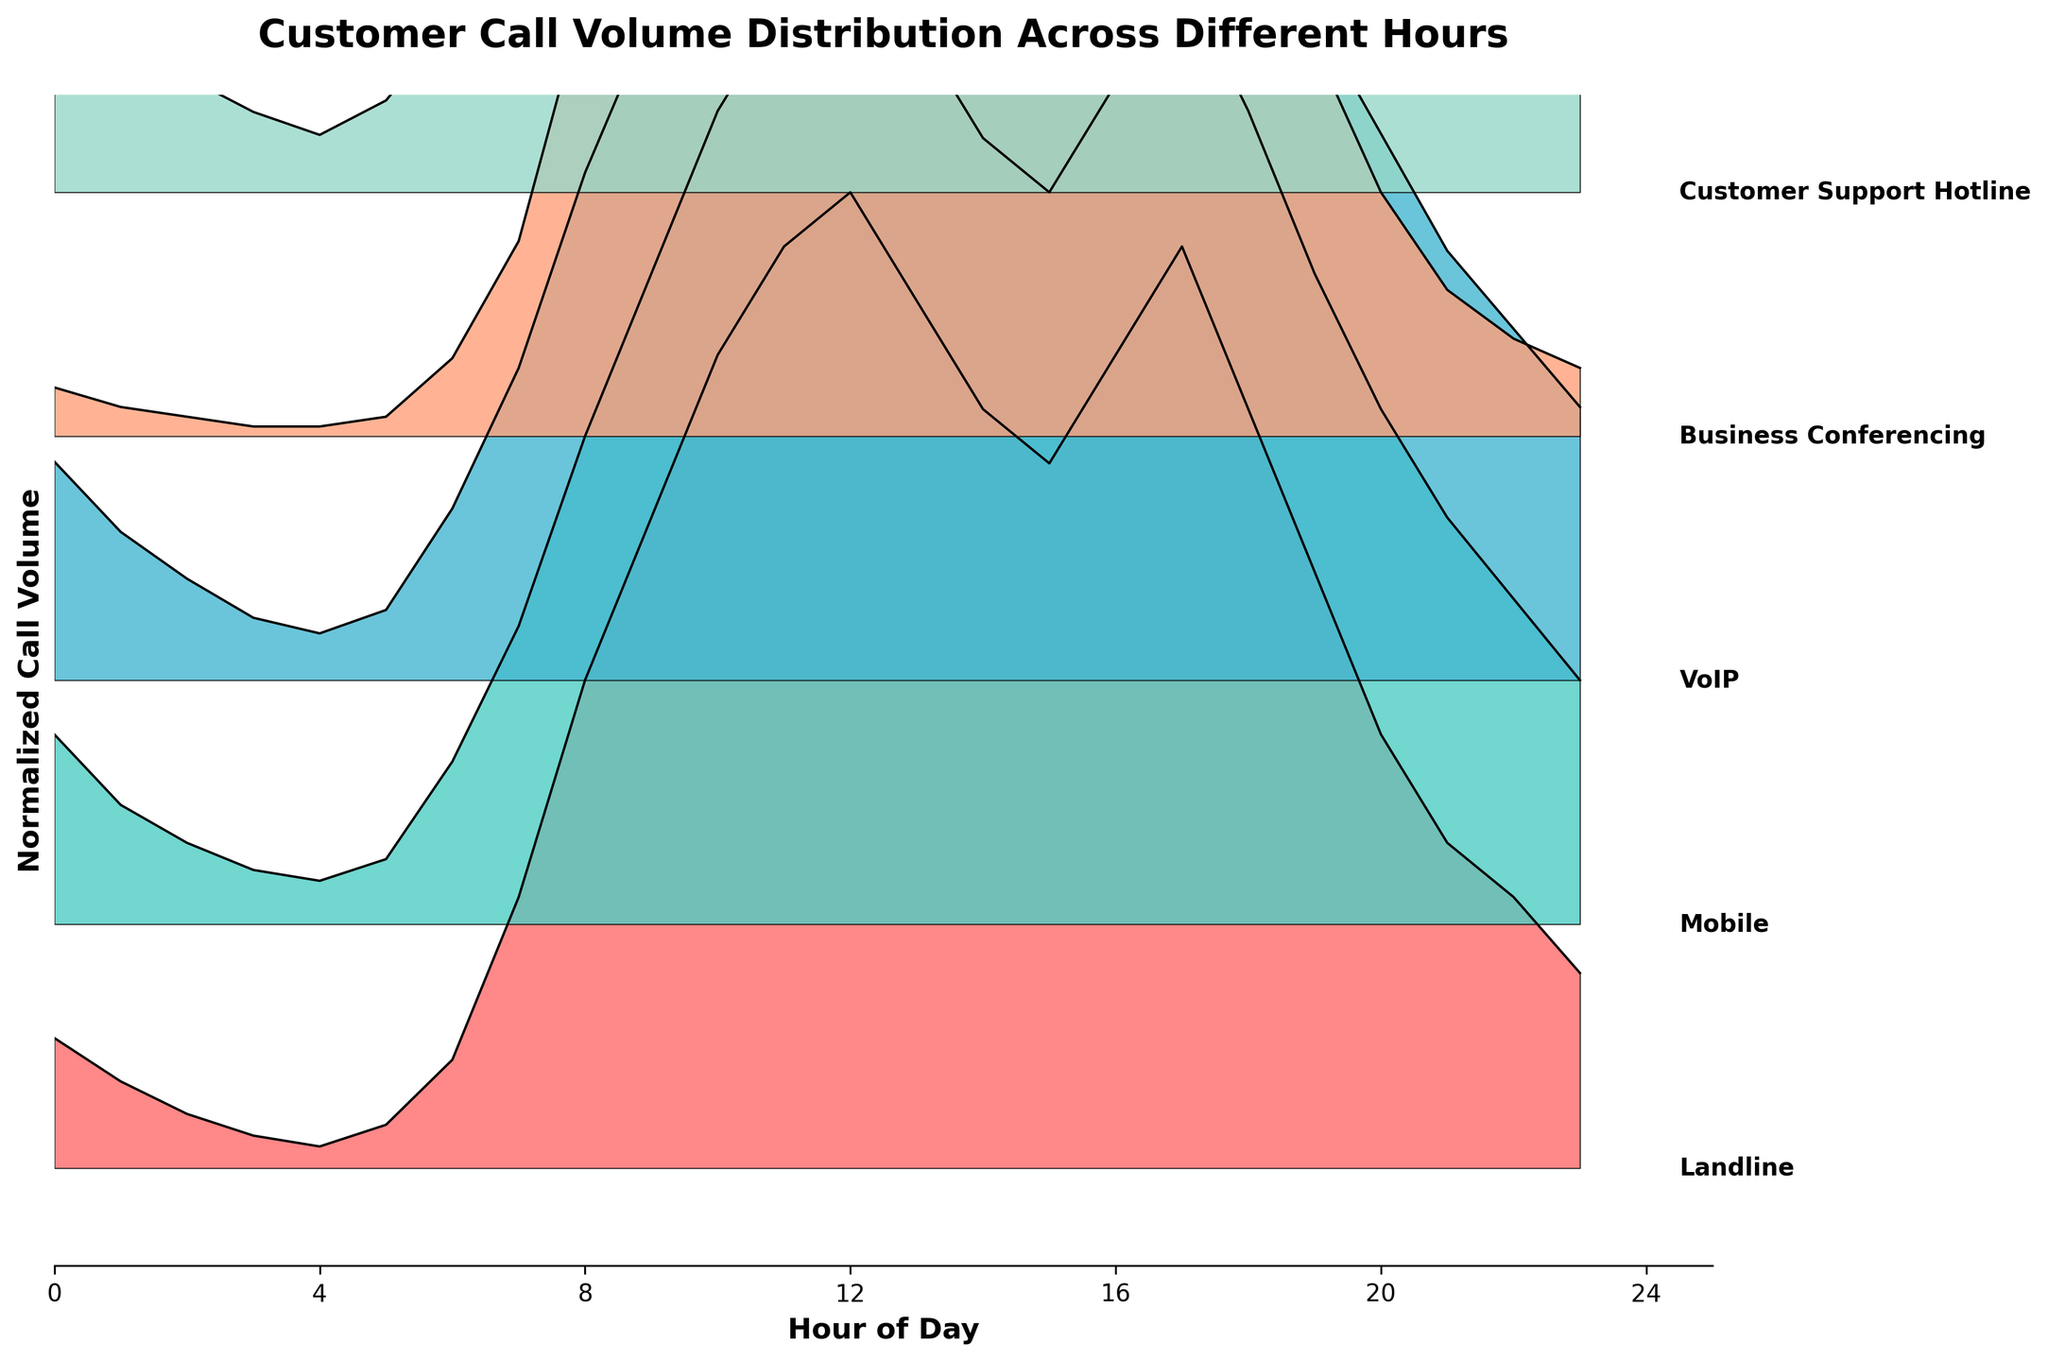What is the title of the diagram? The title is located at the top of the diagram and it directly describes the content of the plot.
Answer: Customer Call Volume Distribution Across Different Hours How many telecom services are compared in the plot? By counting the labeled lines or the filled areas corresponding to the telecom services shown on the right side of the plot, we see five different telecom services.
Answer: Five Which service has the peak normalized call volume around 9 AM? Observing the normalized call volumes at 9 AM, the highest peak can be found in the 'Mobile' service's curve.
Answer: Mobile During which hour does 'Customer Support Hotline' have a noticeable peak? Looking at the normalized call volumes, the 'Customer Support Hotline' line peaks noticeably around 12 PM.
Answer: 12 PM At what times do 'Business Conferencing' and 'VoIP' show similar call volume trends? Both 'Business Conferencing' and 'VoIP' follow a similar rising and falling trend, particularly from 7 AM to 10 AM and then from 4 PM to 6 PM.
Answer: 7 AM to 10 AM and 4 PM to 6 PM How do the call volumes of 'Landline' and 'VoIP' compare throughout the day? Viewing the normalized lines/areas for both services, 'VoIP' generally has higher call volumes as compared to 'Landline', with 'Landline' having smaller peaks and troughs across the day.
Answer: 'VoIP' has higher volumes What is the general trend observed for 'Mobile' and 'Landline' calls from morning to evening? 'Mobile' call volumes increase rapidly in the morning and peak around 11 AM to 12 PM, then gradually decrease. 'Landline' calls also increase but at a slower rate and peak around the same time before declining.
Answer: Slow rise for Landline, rapid for Mobile, peak around 11 AM-12 PM, then decrease Does any service maintain a consistent call volume throughout the day? None of the services maintain a completely consistent call volume; each exhibits noticeable peaks and troughs at various times of the day.
Answer: No During which hours is the peak call volume for 'Mobile' observed? 'Mobile' call volume peaks significantly between 9 AM to 12 PM, with the highest peak around 11 AM.
Answer: 9 AM to 12 PM, peak at 11 AM Is there any hour where all services have low call volumes? Observing the plot, all services tend to have lower call volumes between 1 AM to 4 AM.
Answer: 1 AM to 4 AM 